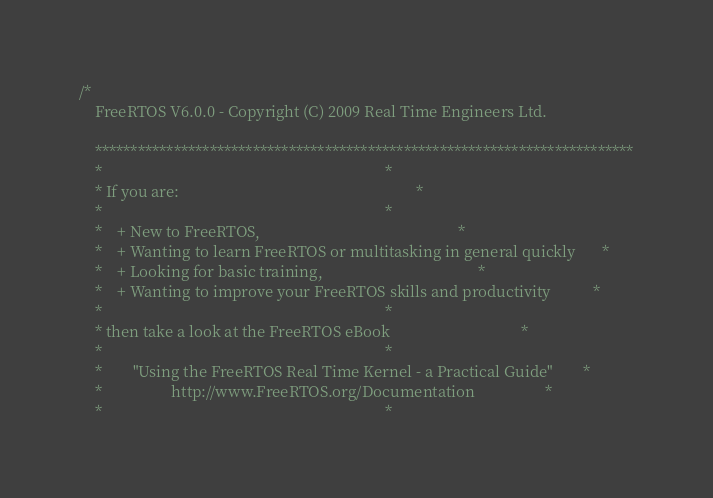<code> <loc_0><loc_0><loc_500><loc_500><_C_>/*
    FreeRTOS V6.0.0 - Copyright (C) 2009 Real Time Engineers Ltd.

    ***************************************************************************
    *                                                                         *
    * If you are:                                                             *
    *                                                                         *
    *    + New to FreeRTOS,                                                   *
    *    + Wanting to learn FreeRTOS or multitasking in general quickly       *
    *    + Looking for basic training,                                        *
    *    + Wanting to improve your FreeRTOS skills and productivity           *
    *                                                                         *
    * then take a look at the FreeRTOS eBook                                  *
    *                                                                         *
    *        "Using the FreeRTOS Real Time Kernel - a Practical Guide"        *
    *                  http://www.FreeRTOS.org/Documentation                  *
    *                                                                         *</code> 